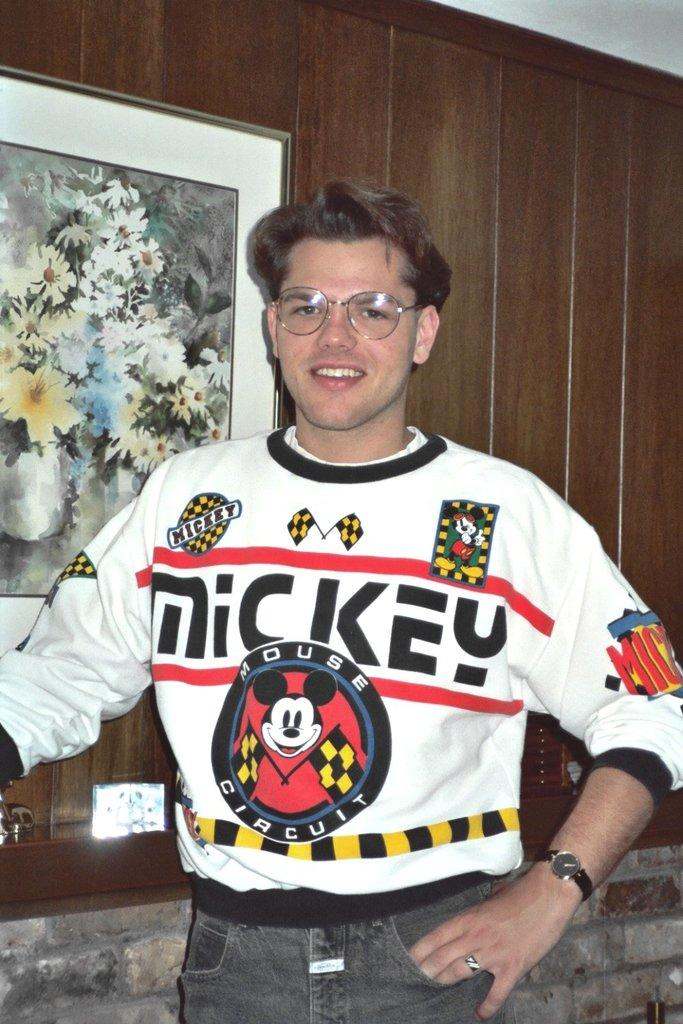Provide a one-sentence caption for the provided image. A young man wearing glasses wears a Mickey House Circuit sweatshirt. 